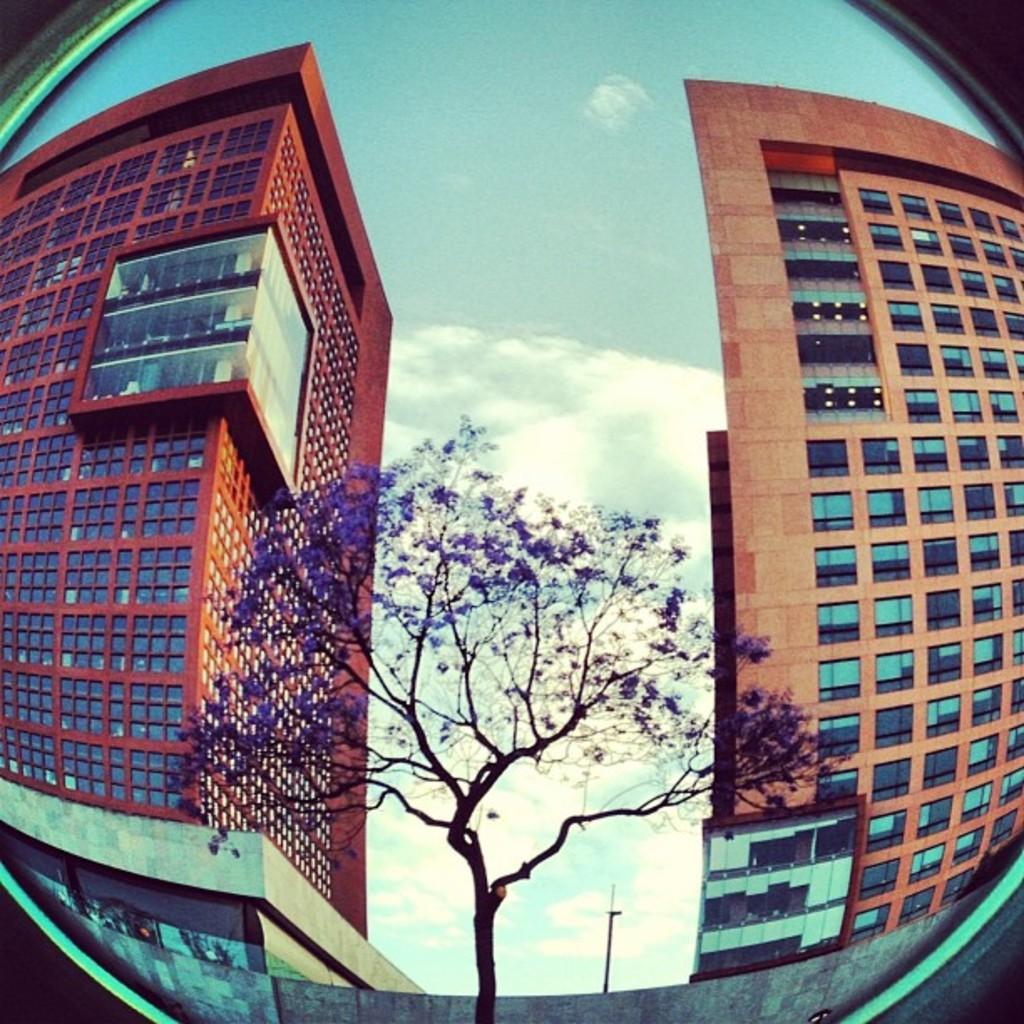Describe this image in one or two sentences. This is an edited picture of some buildings, a tree, a pole and the sky which looks cloudy. 